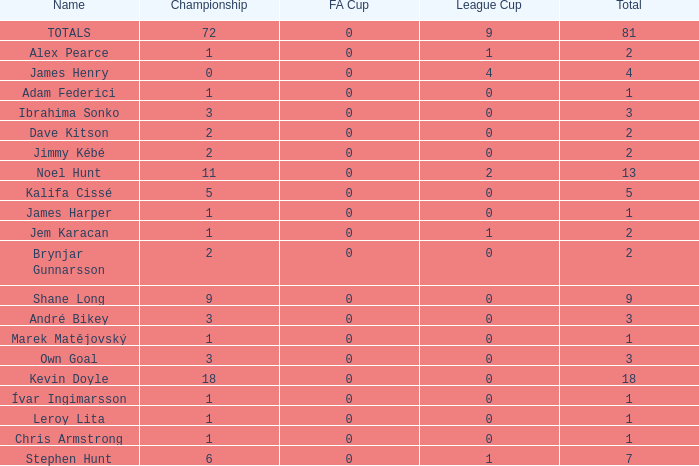What is the total championships of James Henry that has a league cup more than 1? 0.0. 